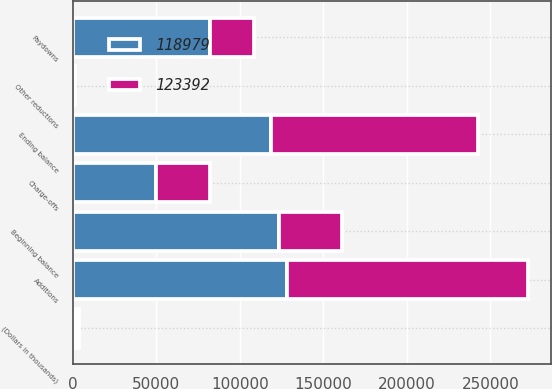Convert chart to OTSL. <chart><loc_0><loc_0><loc_500><loc_500><stacked_bar_chart><ecel><fcel>(Dollars in thousands)<fcel>Beginning balance<fcel>Additions<fcel>Paydowns<fcel>Charge-offs<fcel>Other reductions<fcel>Ending balance<nl><fcel>118979<fcel>2016<fcel>123392<fcel>128338<fcel>81997<fcel>49622<fcel>1132<fcel>118979<nl><fcel>123392<fcel>2015<fcel>38137<fcel>144465<fcel>26590<fcel>32442<fcel>178<fcel>123392<nl></chart> 